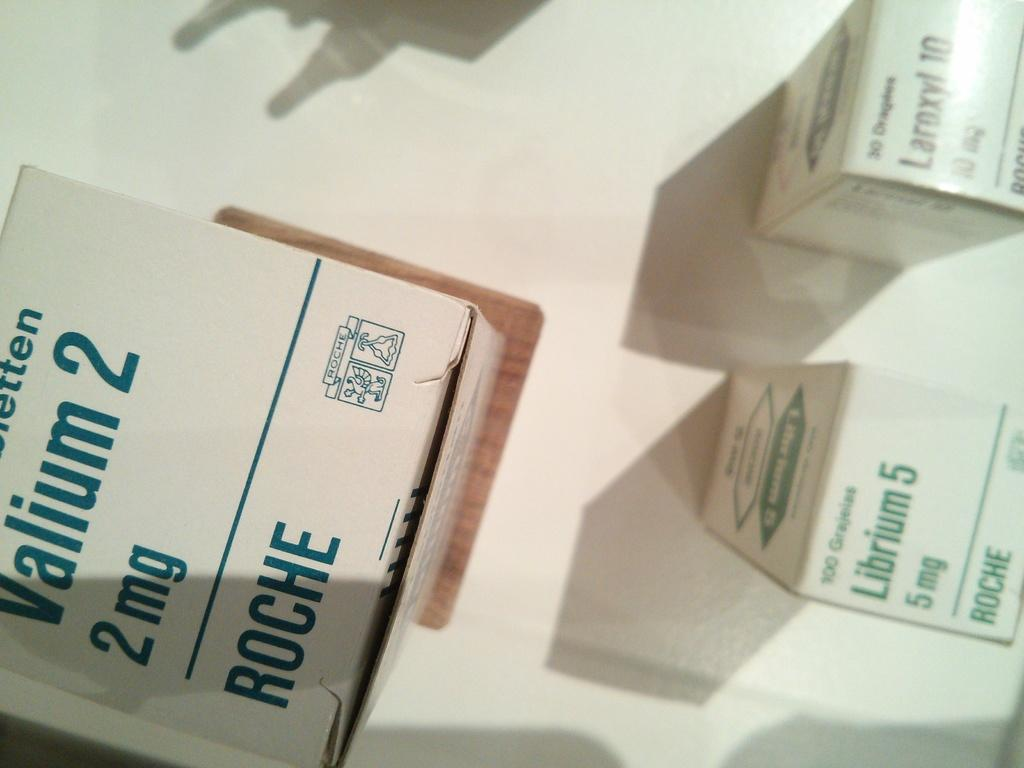<image>
Create a compact narrative representing the image presented. Medical supplies include Valium 2 and Librium 5. 